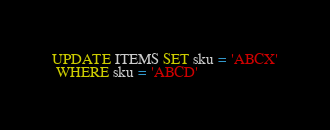Convert code to text. <code><loc_0><loc_0><loc_500><loc_500><_SQL_>UPDATE ITEMS SET sku = 'ABCX'
 WHERE sku = 'ABCD'
</code> 